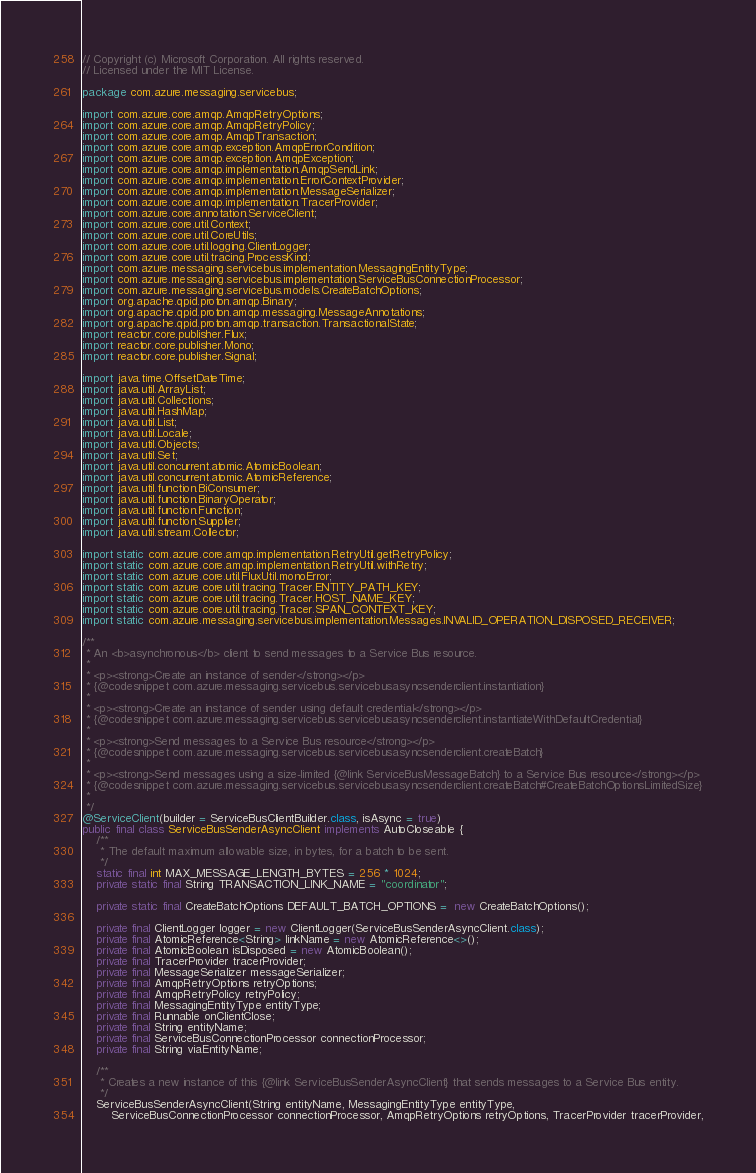<code> <loc_0><loc_0><loc_500><loc_500><_Java_>// Copyright (c) Microsoft Corporation. All rights reserved.
// Licensed under the MIT License.

package com.azure.messaging.servicebus;

import com.azure.core.amqp.AmqpRetryOptions;
import com.azure.core.amqp.AmqpRetryPolicy;
import com.azure.core.amqp.AmqpTransaction;
import com.azure.core.amqp.exception.AmqpErrorCondition;
import com.azure.core.amqp.exception.AmqpException;
import com.azure.core.amqp.implementation.AmqpSendLink;
import com.azure.core.amqp.implementation.ErrorContextProvider;
import com.azure.core.amqp.implementation.MessageSerializer;
import com.azure.core.amqp.implementation.TracerProvider;
import com.azure.core.annotation.ServiceClient;
import com.azure.core.util.Context;
import com.azure.core.util.CoreUtils;
import com.azure.core.util.logging.ClientLogger;
import com.azure.core.util.tracing.ProcessKind;
import com.azure.messaging.servicebus.implementation.MessagingEntityType;
import com.azure.messaging.servicebus.implementation.ServiceBusConnectionProcessor;
import com.azure.messaging.servicebus.models.CreateBatchOptions;
import org.apache.qpid.proton.amqp.Binary;
import org.apache.qpid.proton.amqp.messaging.MessageAnnotations;
import org.apache.qpid.proton.amqp.transaction.TransactionalState;
import reactor.core.publisher.Flux;
import reactor.core.publisher.Mono;
import reactor.core.publisher.Signal;

import java.time.OffsetDateTime;
import java.util.ArrayList;
import java.util.Collections;
import java.util.HashMap;
import java.util.List;
import java.util.Locale;
import java.util.Objects;
import java.util.Set;
import java.util.concurrent.atomic.AtomicBoolean;
import java.util.concurrent.atomic.AtomicReference;
import java.util.function.BiConsumer;
import java.util.function.BinaryOperator;
import java.util.function.Function;
import java.util.function.Supplier;
import java.util.stream.Collector;

import static com.azure.core.amqp.implementation.RetryUtil.getRetryPolicy;
import static com.azure.core.amqp.implementation.RetryUtil.withRetry;
import static com.azure.core.util.FluxUtil.monoError;
import static com.azure.core.util.tracing.Tracer.ENTITY_PATH_KEY;
import static com.azure.core.util.tracing.Tracer.HOST_NAME_KEY;
import static com.azure.core.util.tracing.Tracer.SPAN_CONTEXT_KEY;
import static com.azure.messaging.servicebus.implementation.Messages.INVALID_OPERATION_DISPOSED_RECEIVER;

/**
 * An <b>asynchronous</b> client to send messages to a Service Bus resource.
 *
 * <p><strong>Create an instance of sender</strong></p>
 * {@codesnippet com.azure.messaging.servicebus.servicebusasyncsenderclient.instantiation}
 *
 * <p><strong>Create an instance of sender using default credential</strong></p>
 * {@codesnippet com.azure.messaging.servicebus.servicebusasyncsenderclient.instantiateWithDefaultCredential}
 *
 * <p><strong>Send messages to a Service Bus resource</strong></p>
 * {@codesnippet com.azure.messaging.servicebus.servicebusasyncsenderclient.createBatch}
 *
 * <p><strong>Send messages using a size-limited {@link ServiceBusMessageBatch} to a Service Bus resource</strong></p>
 * {@codesnippet com.azure.messaging.servicebus.servicebusasyncsenderclient.createBatch#CreateBatchOptionsLimitedSize}
 *
 */
@ServiceClient(builder = ServiceBusClientBuilder.class, isAsync = true)
public final class ServiceBusSenderAsyncClient implements AutoCloseable {
    /**
     * The default maximum allowable size, in bytes, for a batch to be sent.
     */
    static final int MAX_MESSAGE_LENGTH_BYTES = 256 * 1024;
    private static final String TRANSACTION_LINK_NAME = "coordinator";

    private static final CreateBatchOptions DEFAULT_BATCH_OPTIONS =  new CreateBatchOptions();

    private final ClientLogger logger = new ClientLogger(ServiceBusSenderAsyncClient.class);
    private final AtomicReference<String> linkName = new AtomicReference<>();
    private final AtomicBoolean isDisposed = new AtomicBoolean();
    private final TracerProvider tracerProvider;
    private final MessageSerializer messageSerializer;
    private final AmqpRetryOptions retryOptions;
    private final AmqpRetryPolicy retryPolicy;
    private final MessagingEntityType entityType;
    private final Runnable onClientClose;
    private final String entityName;
    private final ServiceBusConnectionProcessor connectionProcessor;
    private final String viaEntityName;

    /**
     * Creates a new instance of this {@link ServiceBusSenderAsyncClient} that sends messages to a Service Bus entity.
     */
    ServiceBusSenderAsyncClient(String entityName, MessagingEntityType entityType,
        ServiceBusConnectionProcessor connectionProcessor, AmqpRetryOptions retryOptions, TracerProvider tracerProvider,</code> 